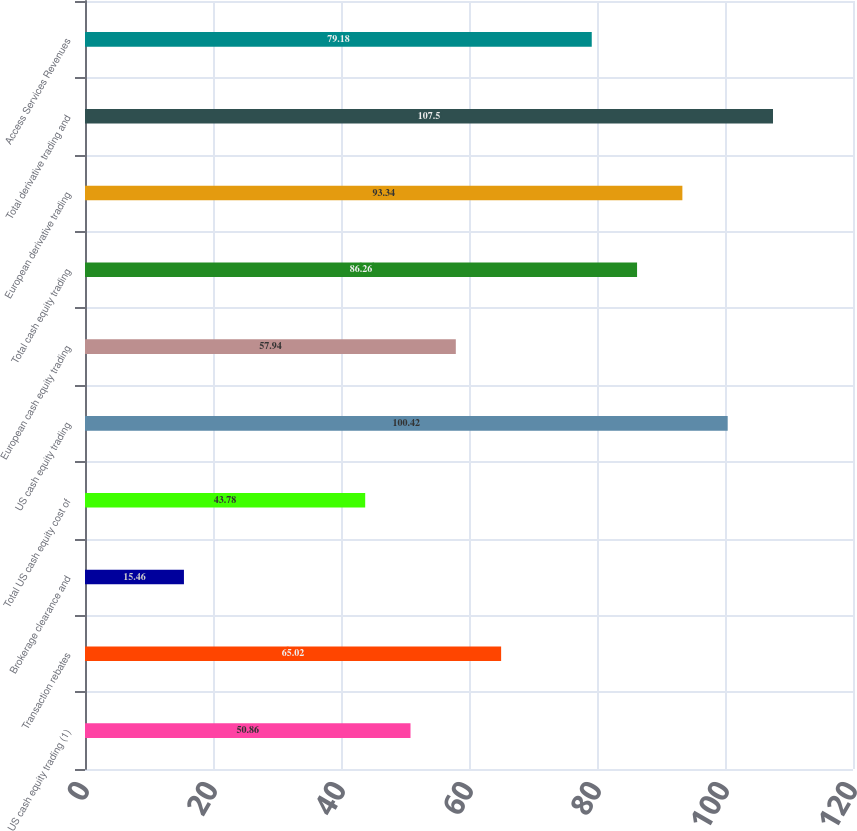Convert chart. <chart><loc_0><loc_0><loc_500><loc_500><bar_chart><fcel>US cash equity trading (1)<fcel>Transaction rebates<fcel>Brokerage clearance and<fcel>Total US cash equity cost of<fcel>US cash equity trading<fcel>European cash equity trading<fcel>Total cash equity trading<fcel>European derivative trading<fcel>Total derivative trading and<fcel>Access Services Revenues<nl><fcel>50.86<fcel>65.02<fcel>15.46<fcel>43.78<fcel>100.42<fcel>57.94<fcel>86.26<fcel>93.34<fcel>107.5<fcel>79.18<nl></chart> 